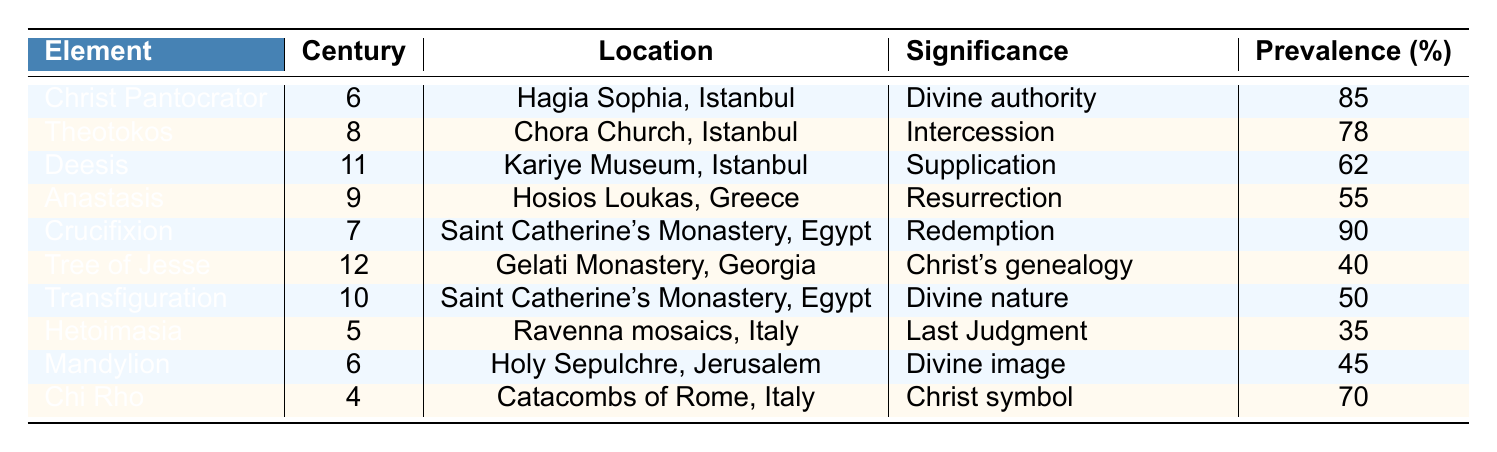What is the significance of the Crucifixion in Byzantine art? The Crucifixion has the significance of "Redemption" as indicated in the table.
Answer: Redemption In which century was the Theotokos predominantly represented? The Theotokos was predominantly represented in the 8th century according to the table.
Answer: 8th century What is the location of the Christ Pantocrator? The Christ Pantocrator is located in Hagia Sophia, Istanbul as per the data in the table.
Answer: Hagia Sophia, Istanbul Which iconographic element has the highest prevalence? The Crucifixion has the highest prevalence at 90%, as evidenced by the table.
Answer: 90% Which elements were represented in the 6th century? The elements represented in the 6th century are Christ Pantocrator and Mandylion based on the table data.
Answer: Christ Pantocrator, Mandylion What is the average prevalence of iconographic elements from the 9th to the 12th centuries? To find the average, we take the prevalence values from the 9th (55), 10th (50), 11th (62), and 12th (40) centuries: (55 + 50 + 62 + 40) = 207. There are 4 elements, so the average is 207/4 = 51.75.
Answer: 51.75 Is the Anastasis associated with divine authority? No, the Anastasis is associated with "Resurrection", not divine authority, as shown in the data.
Answer: No Which two elements appear in religious locations outside of Turkey? The Crucifixion (Egypt) and Tree of Jesse (Georgia) appear in locations outside of Turkey according to the table.
Answer: Crucifixion, Tree of Jesse What is the significance of the Chi Rho? The Chi Rho signifies "Christ symbol" as indicated in the data presented in the table.
Answer: Christ symbol How many elements have a prevalence greater than 60%? The elements with a prevalence greater than 60% are Christ Pantocrator (85), Crucifixion (90), Theotokos (78), and Deesis (62), totaling 4 elements.
Answer: 4 What are the iconographic elements that signify resurrection or intercession? The elements that signify resurrection and intercession are Anastasis (Resurrection) and Theotokos (Intercession) according to the data.
Answer: Anastasis, Theotokos Calculate the total prevalence of all iconographic elements in the table. The total prevalence sums the values: 85 + 78 + 62 + 55 + 90 + 40 + 50 + 35 + 45 + 70 =  510.
Answer: 510 